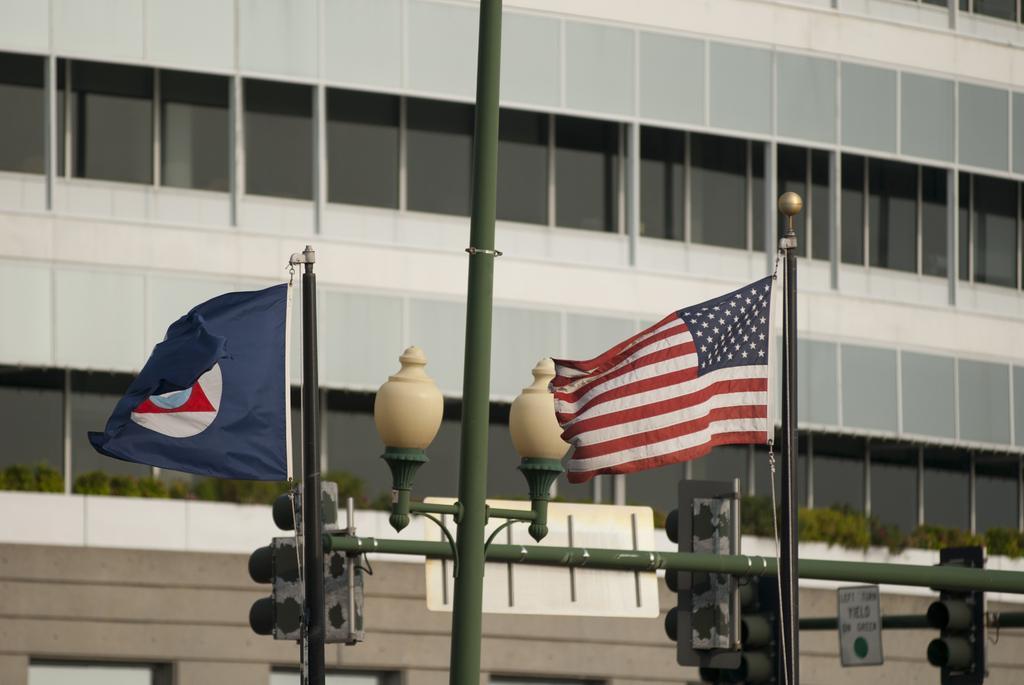Can you describe this image briefly? In this image two flags attached to the poles. There is a street light. Few traffic lights are attached to the poles. Background there is a building having windows. 